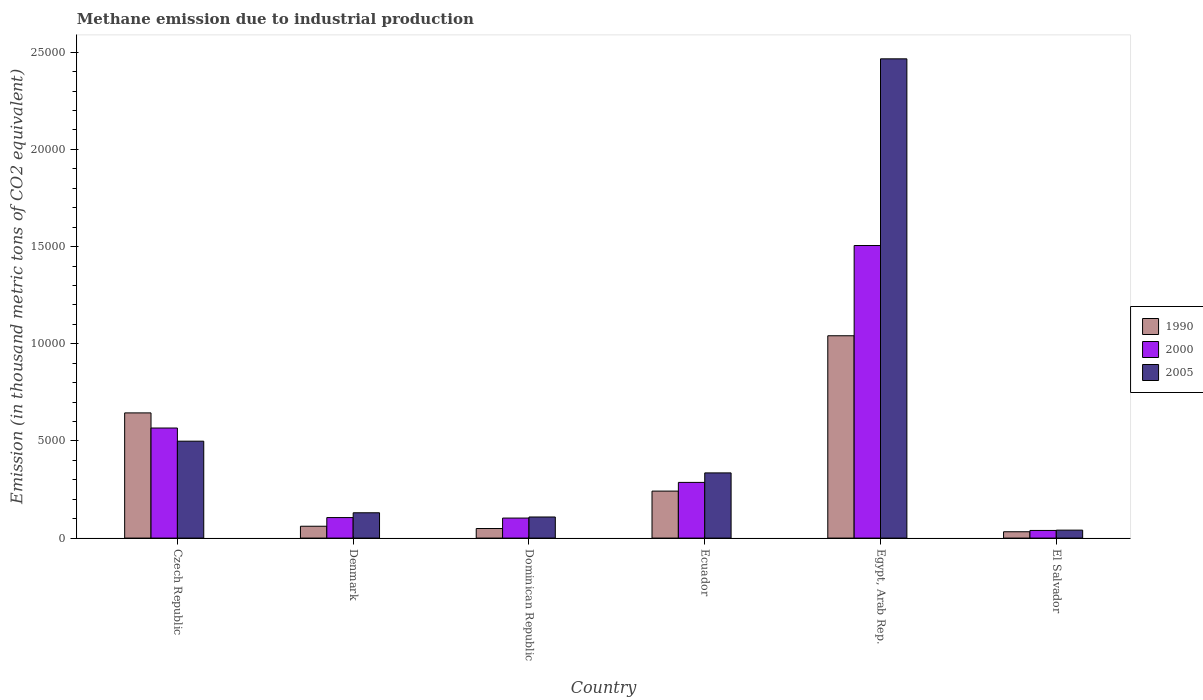How many different coloured bars are there?
Provide a succinct answer. 3. How many groups of bars are there?
Provide a succinct answer. 6. Are the number of bars per tick equal to the number of legend labels?
Ensure brevity in your answer.  Yes. How many bars are there on the 1st tick from the right?
Ensure brevity in your answer.  3. What is the label of the 4th group of bars from the left?
Your response must be concise. Ecuador. What is the amount of methane emitted in 1990 in Egypt, Arab Rep.?
Offer a very short reply. 1.04e+04. Across all countries, what is the maximum amount of methane emitted in 2005?
Provide a succinct answer. 2.47e+04. Across all countries, what is the minimum amount of methane emitted in 2005?
Provide a short and direct response. 409.3. In which country was the amount of methane emitted in 2000 maximum?
Keep it short and to the point. Egypt, Arab Rep. In which country was the amount of methane emitted in 1990 minimum?
Give a very brief answer. El Salvador. What is the total amount of methane emitted in 2000 in the graph?
Your answer should be very brief. 2.61e+04. What is the difference between the amount of methane emitted in 2000 in Denmark and that in El Salvador?
Your answer should be very brief. 662.4. What is the difference between the amount of methane emitted in 2000 in Ecuador and the amount of methane emitted in 2005 in Egypt, Arab Rep.?
Your answer should be very brief. -2.18e+04. What is the average amount of methane emitted in 1990 per country?
Give a very brief answer. 3450.03. What is the difference between the amount of methane emitted of/in 2000 and amount of methane emitted of/in 1990 in Ecuador?
Ensure brevity in your answer.  447.7. What is the ratio of the amount of methane emitted in 2000 in Denmark to that in Ecuador?
Offer a very short reply. 0.37. What is the difference between the highest and the second highest amount of methane emitted in 2000?
Make the answer very short. 2798.1. What is the difference between the highest and the lowest amount of methane emitted in 1990?
Provide a succinct answer. 1.01e+04. In how many countries, is the amount of methane emitted in 2005 greater than the average amount of methane emitted in 2005 taken over all countries?
Your answer should be compact. 1. Is the sum of the amount of methane emitted in 2005 in Czech Republic and Egypt, Arab Rep. greater than the maximum amount of methane emitted in 2000 across all countries?
Ensure brevity in your answer.  Yes. Is it the case that in every country, the sum of the amount of methane emitted in 2005 and amount of methane emitted in 1990 is greater than the amount of methane emitted in 2000?
Make the answer very short. Yes. How many bars are there?
Make the answer very short. 18. Are all the bars in the graph horizontal?
Your response must be concise. No. How many countries are there in the graph?
Provide a succinct answer. 6. Are the values on the major ticks of Y-axis written in scientific E-notation?
Your answer should be compact. No. Does the graph contain any zero values?
Provide a short and direct response. No. Does the graph contain grids?
Provide a short and direct response. No. How are the legend labels stacked?
Make the answer very short. Vertical. What is the title of the graph?
Ensure brevity in your answer.  Methane emission due to industrial production. Does "1960" appear as one of the legend labels in the graph?
Make the answer very short. No. What is the label or title of the X-axis?
Your answer should be very brief. Country. What is the label or title of the Y-axis?
Provide a short and direct response. Emission (in thousand metric tons of CO2 equivalent). What is the Emission (in thousand metric tons of CO2 equivalent) of 1990 in Czech Republic?
Provide a short and direct response. 6442.2. What is the Emission (in thousand metric tons of CO2 equivalent) in 2000 in Czech Republic?
Your response must be concise. 5664.2. What is the Emission (in thousand metric tons of CO2 equivalent) in 2005 in Czech Republic?
Give a very brief answer. 4986.9. What is the Emission (in thousand metric tons of CO2 equivalent) in 1990 in Denmark?
Ensure brevity in your answer.  609.7. What is the Emission (in thousand metric tons of CO2 equivalent) in 2000 in Denmark?
Offer a terse response. 1056. What is the Emission (in thousand metric tons of CO2 equivalent) in 2005 in Denmark?
Your answer should be very brief. 1303.1. What is the Emission (in thousand metric tons of CO2 equivalent) of 1990 in Dominican Republic?
Offer a terse response. 492.1. What is the Emission (in thousand metric tons of CO2 equivalent) in 2000 in Dominican Republic?
Provide a succinct answer. 1030.4. What is the Emission (in thousand metric tons of CO2 equivalent) in 2005 in Dominican Republic?
Make the answer very short. 1085.6. What is the Emission (in thousand metric tons of CO2 equivalent) in 1990 in Ecuador?
Provide a succinct answer. 2418.4. What is the Emission (in thousand metric tons of CO2 equivalent) of 2000 in Ecuador?
Ensure brevity in your answer.  2866.1. What is the Emission (in thousand metric tons of CO2 equivalent) of 2005 in Ecuador?
Give a very brief answer. 3354.7. What is the Emission (in thousand metric tons of CO2 equivalent) of 1990 in Egypt, Arab Rep.?
Provide a succinct answer. 1.04e+04. What is the Emission (in thousand metric tons of CO2 equivalent) of 2000 in Egypt, Arab Rep.?
Keep it short and to the point. 1.51e+04. What is the Emission (in thousand metric tons of CO2 equivalent) of 2005 in Egypt, Arab Rep.?
Keep it short and to the point. 2.47e+04. What is the Emission (in thousand metric tons of CO2 equivalent) in 1990 in El Salvador?
Your answer should be compact. 325.8. What is the Emission (in thousand metric tons of CO2 equivalent) in 2000 in El Salvador?
Your response must be concise. 393.6. What is the Emission (in thousand metric tons of CO2 equivalent) of 2005 in El Salvador?
Your response must be concise. 409.3. Across all countries, what is the maximum Emission (in thousand metric tons of CO2 equivalent) in 1990?
Your answer should be very brief. 1.04e+04. Across all countries, what is the maximum Emission (in thousand metric tons of CO2 equivalent) in 2000?
Give a very brief answer. 1.51e+04. Across all countries, what is the maximum Emission (in thousand metric tons of CO2 equivalent) in 2005?
Your response must be concise. 2.47e+04. Across all countries, what is the minimum Emission (in thousand metric tons of CO2 equivalent) in 1990?
Your answer should be very brief. 325.8. Across all countries, what is the minimum Emission (in thousand metric tons of CO2 equivalent) in 2000?
Offer a very short reply. 393.6. Across all countries, what is the minimum Emission (in thousand metric tons of CO2 equivalent) of 2005?
Provide a succinct answer. 409.3. What is the total Emission (in thousand metric tons of CO2 equivalent) of 1990 in the graph?
Keep it short and to the point. 2.07e+04. What is the total Emission (in thousand metric tons of CO2 equivalent) in 2000 in the graph?
Offer a terse response. 2.61e+04. What is the total Emission (in thousand metric tons of CO2 equivalent) in 2005 in the graph?
Provide a succinct answer. 3.58e+04. What is the difference between the Emission (in thousand metric tons of CO2 equivalent) of 1990 in Czech Republic and that in Denmark?
Keep it short and to the point. 5832.5. What is the difference between the Emission (in thousand metric tons of CO2 equivalent) of 2000 in Czech Republic and that in Denmark?
Your answer should be compact. 4608.2. What is the difference between the Emission (in thousand metric tons of CO2 equivalent) of 2005 in Czech Republic and that in Denmark?
Offer a very short reply. 3683.8. What is the difference between the Emission (in thousand metric tons of CO2 equivalent) of 1990 in Czech Republic and that in Dominican Republic?
Ensure brevity in your answer.  5950.1. What is the difference between the Emission (in thousand metric tons of CO2 equivalent) of 2000 in Czech Republic and that in Dominican Republic?
Ensure brevity in your answer.  4633.8. What is the difference between the Emission (in thousand metric tons of CO2 equivalent) of 2005 in Czech Republic and that in Dominican Republic?
Make the answer very short. 3901.3. What is the difference between the Emission (in thousand metric tons of CO2 equivalent) in 1990 in Czech Republic and that in Ecuador?
Your answer should be compact. 4023.8. What is the difference between the Emission (in thousand metric tons of CO2 equivalent) in 2000 in Czech Republic and that in Ecuador?
Give a very brief answer. 2798.1. What is the difference between the Emission (in thousand metric tons of CO2 equivalent) of 2005 in Czech Republic and that in Ecuador?
Offer a very short reply. 1632.2. What is the difference between the Emission (in thousand metric tons of CO2 equivalent) of 1990 in Czech Republic and that in Egypt, Arab Rep.?
Your answer should be compact. -3969.8. What is the difference between the Emission (in thousand metric tons of CO2 equivalent) in 2000 in Czech Republic and that in Egypt, Arab Rep.?
Give a very brief answer. -9390.7. What is the difference between the Emission (in thousand metric tons of CO2 equivalent) in 2005 in Czech Republic and that in Egypt, Arab Rep.?
Provide a short and direct response. -1.97e+04. What is the difference between the Emission (in thousand metric tons of CO2 equivalent) in 1990 in Czech Republic and that in El Salvador?
Provide a succinct answer. 6116.4. What is the difference between the Emission (in thousand metric tons of CO2 equivalent) in 2000 in Czech Republic and that in El Salvador?
Ensure brevity in your answer.  5270.6. What is the difference between the Emission (in thousand metric tons of CO2 equivalent) of 2005 in Czech Republic and that in El Salvador?
Your response must be concise. 4577.6. What is the difference between the Emission (in thousand metric tons of CO2 equivalent) of 1990 in Denmark and that in Dominican Republic?
Give a very brief answer. 117.6. What is the difference between the Emission (in thousand metric tons of CO2 equivalent) in 2000 in Denmark and that in Dominican Republic?
Offer a very short reply. 25.6. What is the difference between the Emission (in thousand metric tons of CO2 equivalent) of 2005 in Denmark and that in Dominican Republic?
Provide a succinct answer. 217.5. What is the difference between the Emission (in thousand metric tons of CO2 equivalent) of 1990 in Denmark and that in Ecuador?
Offer a very short reply. -1808.7. What is the difference between the Emission (in thousand metric tons of CO2 equivalent) of 2000 in Denmark and that in Ecuador?
Offer a terse response. -1810.1. What is the difference between the Emission (in thousand metric tons of CO2 equivalent) in 2005 in Denmark and that in Ecuador?
Give a very brief answer. -2051.6. What is the difference between the Emission (in thousand metric tons of CO2 equivalent) in 1990 in Denmark and that in Egypt, Arab Rep.?
Make the answer very short. -9802.3. What is the difference between the Emission (in thousand metric tons of CO2 equivalent) of 2000 in Denmark and that in Egypt, Arab Rep.?
Your answer should be very brief. -1.40e+04. What is the difference between the Emission (in thousand metric tons of CO2 equivalent) in 2005 in Denmark and that in Egypt, Arab Rep.?
Make the answer very short. -2.34e+04. What is the difference between the Emission (in thousand metric tons of CO2 equivalent) of 1990 in Denmark and that in El Salvador?
Ensure brevity in your answer.  283.9. What is the difference between the Emission (in thousand metric tons of CO2 equivalent) in 2000 in Denmark and that in El Salvador?
Your answer should be very brief. 662.4. What is the difference between the Emission (in thousand metric tons of CO2 equivalent) in 2005 in Denmark and that in El Salvador?
Give a very brief answer. 893.8. What is the difference between the Emission (in thousand metric tons of CO2 equivalent) in 1990 in Dominican Republic and that in Ecuador?
Your answer should be very brief. -1926.3. What is the difference between the Emission (in thousand metric tons of CO2 equivalent) of 2000 in Dominican Republic and that in Ecuador?
Keep it short and to the point. -1835.7. What is the difference between the Emission (in thousand metric tons of CO2 equivalent) of 2005 in Dominican Republic and that in Ecuador?
Make the answer very short. -2269.1. What is the difference between the Emission (in thousand metric tons of CO2 equivalent) of 1990 in Dominican Republic and that in Egypt, Arab Rep.?
Your answer should be compact. -9919.9. What is the difference between the Emission (in thousand metric tons of CO2 equivalent) of 2000 in Dominican Republic and that in Egypt, Arab Rep.?
Offer a terse response. -1.40e+04. What is the difference between the Emission (in thousand metric tons of CO2 equivalent) in 2005 in Dominican Republic and that in Egypt, Arab Rep.?
Your answer should be compact. -2.36e+04. What is the difference between the Emission (in thousand metric tons of CO2 equivalent) of 1990 in Dominican Republic and that in El Salvador?
Give a very brief answer. 166.3. What is the difference between the Emission (in thousand metric tons of CO2 equivalent) of 2000 in Dominican Republic and that in El Salvador?
Your response must be concise. 636.8. What is the difference between the Emission (in thousand metric tons of CO2 equivalent) of 2005 in Dominican Republic and that in El Salvador?
Give a very brief answer. 676.3. What is the difference between the Emission (in thousand metric tons of CO2 equivalent) in 1990 in Ecuador and that in Egypt, Arab Rep.?
Provide a succinct answer. -7993.6. What is the difference between the Emission (in thousand metric tons of CO2 equivalent) of 2000 in Ecuador and that in Egypt, Arab Rep.?
Make the answer very short. -1.22e+04. What is the difference between the Emission (in thousand metric tons of CO2 equivalent) in 2005 in Ecuador and that in Egypt, Arab Rep.?
Offer a very short reply. -2.13e+04. What is the difference between the Emission (in thousand metric tons of CO2 equivalent) in 1990 in Ecuador and that in El Salvador?
Keep it short and to the point. 2092.6. What is the difference between the Emission (in thousand metric tons of CO2 equivalent) of 2000 in Ecuador and that in El Salvador?
Provide a succinct answer. 2472.5. What is the difference between the Emission (in thousand metric tons of CO2 equivalent) of 2005 in Ecuador and that in El Salvador?
Ensure brevity in your answer.  2945.4. What is the difference between the Emission (in thousand metric tons of CO2 equivalent) in 1990 in Egypt, Arab Rep. and that in El Salvador?
Make the answer very short. 1.01e+04. What is the difference between the Emission (in thousand metric tons of CO2 equivalent) of 2000 in Egypt, Arab Rep. and that in El Salvador?
Provide a succinct answer. 1.47e+04. What is the difference between the Emission (in thousand metric tons of CO2 equivalent) in 2005 in Egypt, Arab Rep. and that in El Salvador?
Offer a terse response. 2.43e+04. What is the difference between the Emission (in thousand metric tons of CO2 equivalent) of 1990 in Czech Republic and the Emission (in thousand metric tons of CO2 equivalent) of 2000 in Denmark?
Provide a succinct answer. 5386.2. What is the difference between the Emission (in thousand metric tons of CO2 equivalent) in 1990 in Czech Republic and the Emission (in thousand metric tons of CO2 equivalent) in 2005 in Denmark?
Make the answer very short. 5139.1. What is the difference between the Emission (in thousand metric tons of CO2 equivalent) of 2000 in Czech Republic and the Emission (in thousand metric tons of CO2 equivalent) of 2005 in Denmark?
Your response must be concise. 4361.1. What is the difference between the Emission (in thousand metric tons of CO2 equivalent) of 1990 in Czech Republic and the Emission (in thousand metric tons of CO2 equivalent) of 2000 in Dominican Republic?
Ensure brevity in your answer.  5411.8. What is the difference between the Emission (in thousand metric tons of CO2 equivalent) in 1990 in Czech Republic and the Emission (in thousand metric tons of CO2 equivalent) in 2005 in Dominican Republic?
Ensure brevity in your answer.  5356.6. What is the difference between the Emission (in thousand metric tons of CO2 equivalent) in 2000 in Czech Republic and the Emission (in thousand metric tons of CO2 equivalent) in 2005 in Dominican Republic?
Keep it short and to the point. 4578.6. What is the difference between the Emission (in thousand metric tons of CO2 equivalent) in 1990 in Czech Republic and the Emission (in thousand metric tons of CO2 equivalent) in 2000 in Ecuador?
Offer a very short reply. 3576.1. What is the difference between the Emission (in thousand metric tons of CO2 equivalent) in 1990 in Czech Republic and the Emission (in thousand metric tons of CO2 equivalent) in 2005 in Ecuador?
Provide a succinct answer. 3087.5. What is the difference between the Emission (in thousand metric tons of CO2 equivalent) of 2000 in Czech Republic and the Emission (in thousand metric tons of CO2 equivalent) of 2005 in Ecuador?
Your answer should be compact. 2309.5. What is the difference between the Emission (in thousand metric tons of CO2 equivalent) in 1990 in Czech Republic and the Emission (in thousand metric tons of CO2 equivalent) in 2000 in Egypt, Arab Rep.?
Keep it short and to the point. -8612.7. What is the difference between the Emission (in thousand metric tons of CO2 equivalent) in 1990 in Czech Republic and the Emission (in thousand metric tons of CO2 equivalent) in 2005 in Egypt, Arab Rep.?
Offer a terse response. -1.82e+04. What is the difference between the Emission (in thousand metric tons of CO2 equivalent) of 2000 in Czech Republic and the Emission (in thousand metric tons of CO2 equivalent) of 2005 in Egypt, Arab Rep.?
Make the answer very short. -1.90e+04. What is the difference between the Emission (in thousand metric tons of CO2 equivalent) in 1990 in Czech Republic and the Emission (in thousand metric tons of CO2 equivalent) in 2000 in El Salvador?
Your response must be concise. 6048.6. What is the difference between the Emission (in thousand metric tons of CO2 equivalent) of 1990 in Czech Republic and the Emission (in thousand metric tons of CO2 equivalent) of 2005 in El Salvador?
Your response must be concise. 6032.9. What is the difference between the Emission (in thousand metric tons of CO2 equivalent) in 2000 in Czech Republic and the Emission (in thousand metric tons of CO2 equivalent) in 2005 in El Salvador?
Ensure brevity in your answer.  5254.9. What is the difference between the Emission (in thousand metric tons of CO2 equivalent) in 1990 in Denmark and the Emission (in thousand metric tons of CO2 equivalent) in 2000 in Dominican Republic?
Make the answer very short. -420.7. What is the difference between the Emission (in thousand metric tons of CO2 equivalent) in 1990 in Denmark and the Emission (in thousand metric tons of CO2 equivalent) in 2005 in Dominican Republic?
Your response must be concise. -475.9. What is the difference between the Emission (in thousand metric tons of CO2 equivalent) in 2000 in Denmark and the Emission (in thousand metric tons of CO2 equivalent) in 2005 in Dominican Republic?
Offer a very short reply. -29.6. What is the difference between the Emission (in thousand metric tons of CO2 equivalent) of 1990 in Denmark and the Emission (in thousand metric tons of CO2 equivalent) of 2000 in Ecuador?
Your answer should be very brief. -2256.4. What is the difference between the Emission (in thousand metric tons of CO2 equivalent) in 1990 in Denmark and the Emission (in thousand metric tons of CO2 equivalent) in 2005 in Ecuador?
Give a very brief answer. -2745. What is the difference between the Emission (in thousand metric tons of CO2 equivalent) in 2000 in Denmark and the Emission (in thousand metric tons of CO2 equivalent) in 2005 in Ecuador?
Provide a short and direct response. -2298.7. What is the difference between the Emission (in thousand metric tons of CO2 equivalent) in 1990 in Denmark and the Emission (in thousand metric tons of CO2 equivalent) in 2000 in Egypt, Arab Rep.?
Provide a short and direct response. -1.44e+04. What is the difference between the Emission (in thousand metric tons of CO2 equivalent) in 1990 in Denmark and the Emission (in thousand metric tons of CO2 equivalent) in 2005 in Egypt, Arab Rep.?
Keep it short and to the point. -2.41e+04. What is the difference between the Emission (in thousand metric tons of CO2 equivalent) in 2000 in Denmark and the Emission (in thousand metric tons of CO2 equivalent) in 2005 in Egypt, Arab Rep.?
Make the answer very short. -2.36e+04. What is the difference between the Emission (in thousand metric tons of CO2 equivalent) of 1990 in Denmark and the Emission (in thousand metric tons of CO2 equivalent) of 2000 in El Salvador?
Ensure brevity in your answer.  216.1. What is the difference between the Emission (in thousand metric tons of CO2 equivalent) of 1990 in Denmark and the Emission (in thousand metric tons of CO2 equivalent) of 2005 in El Salvador?
Ensure brevity in your answer.  200.4. What is the difference between the Emission (in thousand metric tons of CO2 equivalent) of 2000 in Denmark and the Emission (in thousand metric tons of CO2 equivalent) of 2005 in El Salvador?
Make the answer very short. 646.7. What is the difference between the Emission (in thousand metric tons of CO2 equivalent) in 1990 in Dominican Republic and the Emission (in thousand metric tons of CO2 equivalent) in 2000 in Ecuador?
Give a very brief answer. -2374. What is the difference between the Emission (in thousand metric tons of CO2 equivalent) of 1990 in Dominican Republic and the Emission (in thousand metric tons of CO2 equivalent) of 2005 in Ecuador?
Make the answer very short. -2862.6. What is the difference between the Emission (in thousand metric tons of CO2 equivalent) in 2000 in Dominican Republic and the Emission (in thousand metric tons of CO2 equivalent) in 2005 in Ecuador?
Your answer should be very brief. -2324.3. What is the difference between the Emission (in thousand metric tons of CO2 equivalent) of 1990 in Dominican Republic and the Emission (in thousand metric tons of CO2 equivalent) of 2000 in Egypt, Arab Rep.?
Keep it short and to the point. -1.46e+04. What is the difference between the Emission (in thousand metric tons of CO2 equivalent) in 1990 in Dominican Republic and the Emission (in thousand metric tons of CO2 equivalent) in 2005 in Egypt, Arab Rep.?
Ensure brevity in your answer.  -2.42e+04. What is the difference between the Emission (in thousand metric tons of CO2 equivalent) of 2000 in Dominican Republic and the Emission (in thousand metric tons of CO2 equivalent) of 2005 in Egypt, Arab Rep.?
Make the answer very short. -2.36e+04. What is the difference between the Emission (in thousand metric tons of CO2 equivalent) in 1990 in Dominican Republic and the Emission (in thousand metric tons of CO2 equivalent) in 2000 in El Salvador?
Give a very brief answer. 98.5. What is the difference between the Emission (in thousand metric tons of CO2 equivalent) of 1990 in Dominican Republic and the Emission (in thousand metric tons of CO2 equivalent) of 2005 in El Salvador?
Provide a short and direct response. 82.8. What is the difference between the Emission (in thousand metric tons of CO2 equivalent) of 2000 in Dominican Republic and the Emission (in thousand metric tons of CO2 equivalent) of 2005 in El Salvador?
Your response must be concise. 621.1. What is the difference between the Emission (in thousand metric tons of CO2 equivalent) of 1990 in Ecuador and the Emission (in thousand metric tons of CO2 equivalent) of 2000 in Egypt, Arab Rep.?
Offer a very short reply. -1.26e+04. What is the difference between the Emission (in thousand metric tons of CO2 equivalent) in 1990 in Ecuador and the Emission (in thousand metric tons of CO2 equivalent) in 2005 in Egypt, Arab Rep.?
Your response must be concise. -2.22e+04. What is the difference between the Emission (in thousand metric tons of CO2 equivalent) of 2000 in Ecuador and the Emission (in thousand metric tons of CO2 equivalent) of 2005 in Egypt, Arab Rep.?
Your answer should be very brief. -2.18e+04. What is the difference between the Emission (in thousand metric tons of CO2 equivalent) of 1990 in Ecuador and the Emission (in thousand metric tons of CO2 equivalent) of 2000 in El Salvador?
Provide a short and direct response. 2024.8. What is the difference between the Emission (in thousand metric tons of CO2 equivalent) in 1990 in Ecuador and the Emission (in thousand metric tons of CO2 equivalent) in 2005 in El Salvador?
Your answer should be compact. 2009.1. What is the difference between the Emission (in thousand metric tons of CO2 equivalent) in 2000 in Ecuador and the Emission (in thousand metric tons of CO2 equivalent) in 2005 in El Salvador?
Give a very brief answer. 2456.8. What is the difference between the Emission (in thousand metric tons of CO2 equivalent) in 1990 in Egypt, Arab Rep. and the Emission (in thousand metric tons of CO2 equivalent) in 2000 in El Salvador?
Provide a short and direct response. 1.00e+04. What is the difference between the Emission (in thousand metric tons of CO2 equivalent) in 1990 in Egypt, Arab Rep. and the Emission (in thousand metric tons of CO2 equivalent) in 2005 in El Salvador?
Your answer should be compact. 1.00e+04. What is the difference between the Emission (in thousand metric tons of CO2 equivalent) of 2000 in Egypt, Arab Rep. and the Emission (in thousand metric tons of CO2 equivalent) of 2005 in El Salvador?
Give a very brief answer. 1.46e+04. What is the average Emission (in thousand metric tons of CO2 equivalent) of 1990 per country?
Ensure brevity in your answer.  3450.03. What is the average Emission (in thousand metric tons of CO2 equivalent) of 2000 per country?
Your response must be concise. 4344.2. What is the average Emission (in thousand metric tons of CO2 equivalent) of 2005 per country?
Provide a succinct answer. 5966.92. What is the difference between the Emission (in thousand metric tons of CO2 equivalent) in 1990 and Emission (in thousand metric tons of CO2 equivalent) in 2000 in Czech Republic?
Ensure brevity in your answer.  778. What is the difference between the Emission (in thousand metric tons of CO2 equivalent) in 1990 and Emission (in thousand metric tons of CO2 equivalent) in 2005 in Czech Republic?
Provide a short and direct response. 1455.3. What is the difference between the Emission (in thousand metric tons of CO2 equivalent) of 2000 and Emission (in thousand metric tons of CO2 equivalent) of 2005 in Czech Republic?
Give a very brief answer. 677.3. What is the difference between the Emission (in thousand metric tons of CO2 equivalent) of 1990 and Emission (in thousand metric tons of CO2 equivalent) of 2000 in Denmark?
Your answer should be very brief. -446.3. What is the difference between the Emission (in thousand metric tons of CO2 equivalent) in 1990 and Emission (in thousand metric tons of CO2 equivalent) in 2005 in Denmark?
Offer a terse response. -693.4. What is the difference between the Emission (in thousand metric tons of CO2 equivalent) of 2000 and Emission (in thousand metric tons of CO2 equivalent) of 2005 in Denmark?
Provide a succinct answer. -247.1. What is the difference between the Emission (in thousand metric tons of CO2 equivalent) in 1990 and Emission (in thousand metric tons of CO2 equivalent) in 2000 in Dominican Republic?
Keep it short and to the point. -538.3. What is the difference between the Emission (in thousand metric tons of CO2 equivalent) in 1990 and Emission (in thousand metric tons of CO2 equivalent) in 2005 in Dominican Republic?
Ensure brevity in your answer.  -593.5. What is the difference between the Emission (in thousand metric tons of CO2 equivalent) of 2000 and Emission (in thousand metric tons of CO2 equivalent) of 2005 in Dominican Republic?
Provide a short and direct response. -55.2. What is the difference between the Emission (in thousand metric tons of CO2 equivalent) in 1990 and Emission (in thousand metric tons of CO2 equivalent) in 2000 in Ecuador?
Provide a short and direct response. -447.7. What is the difference between the Emission (in thousand metric tons of CO2 equivalent) of 1990 and Emission (in thousand metric tons of CO2 equivalent) of 2005 in Ecuador?
Your response must be concise. -936.3. What is the difference between the Emission (in thousand metric tons of CO2 equivalent) of 2000 and Emission (in thousand metric tons of CO2 equivalent) of 2005 in Ecuador?
Provide a short and direct response. -488.6. What is the difference between the Emission (in thousand metric tons of CO2 equivalent) in 1990 and Emission (in thousand metric tons of CO2 equivalent) in 2000 in Egypt, Arab Rep.?
Provide a short and direct response. -4642.9. What is the difference between the Emission (in thousand metric tons of CO2 equivalent) of 1990 and Emission (in thousand metric tons of CO2 equivalent) of 2005 in Egypt, Arab Rep.?
Your answer should be compact. -1.42e+04. What is the difference between the Emission (in thousand metric tons of CO2 equivalent) in 2000 and Emission (in thousand metric tons of CO2 equivalent) in 2005 in Egypt, Arab Rep.?
Offer a terse response. -9607. What is the difference between the Emission (in thousand metric tons of CO2 equivalent) in 1990 and Emission (in thousand metric tons of CO2 equivalent) in 2000 in El Salvador?
Your answer should be very brief. -67.8. What is the difference between the Emission (in thousand metric tons of CO2 equivalent) of 1990 and Emission (in thousand metric tons of CO2 equivalent) of 2005 in El Salvador?
Provide a succinct answer. -83.5. What is the difference between the Emission (in thousand metric tons of CO2 equivalent) in 2000 and Emission (in thousand metric tons of CO2 equivalent) in 2005 in El Salvador?
Your answer should be very brief. -15.7. What is the ratio of the Emission (in thousand metric tons of CO2 equivalent) in 1990 in Czech Republic to that in Denmark?
Provide a succinct answer. 10.57. What is the ratio of the Emission (in thousand metric tons of CO2 equivalent) in 2000 in Czech Republic to that in Denmark?
Ensure brevity in your answer.  5.36. What is the ratio of the Emission (in thousand metric tons of CO2 equivalent) in 2005 in Czech Republic to that in Denmark?
Give a very brief answer. 3.83. What is the ratio of the Emission (in thousand metric tons of CO2 equivalent) in 1990 in Czech Republic to that in Dominican Republic?
Your answer should be compact. 13.09. What is the ratio of the Emission (in thousand metric tons of CO2 equivalent) in 2000 in Czech Republic to that in Dominican Republic?
Give a very brief answer. 5.5. What is the ratio of the Emission (in thousand metric tons of CO2 equivalent) of 2005 in Czech Republic to that in Dominican Republic?
Offer a terse response. 4.59. What is the ratio of the Emission (in thousand metric tons of CO2 equivalent) of 1990 in Czech Republic to that in Ecuador?
Make the answer very short. 2.66. What is the ratio of the Emission (in thousand metric tons of CO2 equivalent) of 2000 in Czech Republic to that in Ecuador?
Keep it short and to the point. 1.98. What is the ratio of the Emission (in thousand metric tons of CO2 equivalent) of 2005 in Czech Republic to that in Ecuador?
Your response must be concise. 1.49. What is the ratio of the Emission (in thousand metric tons of CO2 equivalent) of 1990 in Czech Republic to that in Egypt, Arab Rep.?
Give a very brief answer. 0.62. What is the ratio of the Emission (in thousand metric tons of CO2 equivalent) in 2000 in Czech Republic to that in Egypt, Arab Rep.?
Keep it short and to the point. 0.38. What is the ratio of the Emission (in thousand metric tons of CO2 equivalent) of 2005 in Czech Republic to that in Egypt, Arab Rep.?
Provide a short and direct response. 0.2. What is the ratio of the Emission (in thousand metric tons of CO2 equivalent) of 1990 in Czech Republic to that in El Salvador?
Offer a terse response. 19.77. What is the ratio of the Emission (in thousand metric tons of CO2 equivalent) in 2000 in Czech Republic to that in El Salvador?
Ensure brevity in your answer.  14.39. What is the ratio of the Emission (in thousand metric tons of CO2 equivalent) in 2005 in Czech Republic to that in El Salvador?
Give a very brief answer. 12.18. What is the ratio of the Emission (in thousand metric tons of CO2 equivalent) in 1990 in Denmark to that in Dominican Republic?
Ensure brevity in your answer.  1.24. What is the ratio of the Emission (in thousand metric tons of CO2 equivalent) of 2000 in Denmark to that in Dominican Republic?
Offer a terse response. 1.02. What is the ratio of the Emission (in thousand metric tons of CO2 equivalent) in 2005 in Denmark to that in Dominican Republic?
Your response must be concise. 1.2. What is the ratio of the Emission (in thousand metric tons of CO2 equivalent) in 1990 in Denmark to that in Ecuador?
Provide a succinct answer. 0.25. What is the ratio of the Emission (in thousand metric tons of CO2 equivalent) of 2000 in Denmark to that in Ecuador?
Offer a terse response. 0.37. What is the ratio of the Emission (in thousand metric tons of CO2 equivalent) in 2005 in Denmark to that in Ecuador?
Make the answer very short. 0.39. What is the ratio of the Emission (in thousand metric tons of CO2 equivalent) of 1990 in Denmark to that in Egypt, Arab Rep.?
Offer a terse response. 0.06. What is the ratio of the Emission (in thousand metric tons of CO2 equivalent) in 2000 in Denmark to that in Egypt, Arab Rep.?
Ensure brevity in your answer.  0.07. What is the ratio of the Emission (in thousand metric tons of CO2 equivalent) in 2005 in Denmark to that in Egypt, Arab Rep.?
Give a very brief answer. 0.05. What is the ratio of the Emission (in thousand metric tons of CO2 equivalent) in 1990 in Denmark to that in El Salvador?
Your answer should be compact. 1.87. What is the ratio of the Emission (in thousand metric tons of CO2 equivalent) of 2000 in Denmark to that in El Salvador?
Keep it short and to the point. 2.68. What is the ratio of the Emission (in thousand metric tons of CO2 equivalent) of 2005 in Denmark to that in El Salvador?
Provide a succinct answer. 3.18. What is the ratio of the Emission (in thousand metric tons of CO2 equivalent) in 1990 in Dominican Republic to that in Ecuador?
Give a very brief answer. 0.2. What is the ratio of the Emission (in thousand metric tons of CO2 equivalent) of 2000 in Dominican Republic to that in Ecuador?
Ensure brevity in your answer.  0.36. What is the ratio of the Emission (in thousand metric tons of CO2 equivalent) of 2005 in Dominican Republic to that in Ecuador?
Offer a terse response. 0.32. What is the ratio of the Emission (in thousand metric tons of CO2 equivalent) in 1990 in Dominican Republic to that in Egypt, Arab Rep.?
Your answer should be very brief. 0.05. What is the ratio of the Emission (in thousand metric tons of CO2 equivalent) of 2000 in Dominican Republic to that in Egypt, Arab Rep.?
Offer a terse response. 0.07. What is the ratio of the Emission (in thousand metric tons of CO2 equivalent) in 2005 in Dominican Republic to that in Egypt, Arab Rep.?
Offer a terse response. 0.04. What is the ratio of the Emission (in thousand metric tons of CO2 equivalent) of 1990 in Dominican Republic to that in El Salvador?
Ensure brevity in your answer.  1.51. What is the ratio of the Emission (in thousand metric tons of CO2 equivalent) of 2000 in Dominican Republic to that in El Salvador?
Your response must be concise. 2.62. What is the ratio of the Emission (in thousand metric tons of CO2 equivalent) of 2005 in Dominican Republic to that in El Salvador?
Provide a short and direct response. 2.65. What is the ratio of the Emission (in thousand metric tons of CO2 equivalent) in 1990 in Ecuador to that in Egypt, Arab Rep.?
Provide a succinct answer. 0.23. What is the ratio of the Emission (in thousand metric tons of CO2 equivalent) of 2000 in Ecuador to that in Egypt, Arab Rep.?
Give a very brief answer. 0.19. What is the ratio of the Emission (in thousand metric tons of CO2 equivalent) of 2005 in Ecuador to that in Egypt, Arab Rep.?
Offer a very short reply. 0.14. What is the ratio of the Emission (in thousand metric tons of CO2 equivalent) in 1990 in Ecuador to that in El Salvador?
Your answer should be very brief. 7.42. What is the ratio of the Emission (in thousand metric tons of CO2 equivalent) of 2000 in Ecuador to that in El Salvador?
Give a very brief answer. 7.28. What is the ratio of the Emission (in thousand metric tons of CO2 equivalent) of 2005 in Ecuador to that in El Salvador?
Your answer should be very brief. 8.2. What is the ratio of the Emission (in thousand metric tons of CO2 equivalent) of 1990 in Egypt, Arab Rep. to that in El Salvador?
Your answer should be compact. 31.96. What is the ratio of the Emission (in thousand metric tons of CO2 equivalent) of 2000 in Egypt, Arab Rep. to that in El Salvador?
Your answer should be very brief. 38.25. What is the ratio of the Emission (in thousand metric tons of CO2 equivalent) of 2005 in Egypt, Arab Rep. to that in El Salvador?
Give a very brief answer. 60.25. What is the difference between the highest and the second highest Emission (in thousand metric tons of CO2 equivalent) of 1990?
Give a very brief answer. 3969.8. What is the difference between the highest and the second highest Emission (in thousand metric tons of CO2 equivalent) of 2000?
Give a very brief answer. 9390.7. What is the difference between the highest and the second highest Emission (in thousand metric tons of CO2 equivalent) of 2005?
Offer a very short reply. 1.97e+04. What is the difference between the highest and the lowest Emission (in thousand metric tons of CO2 equivalent) of 1990?
Offer a terse response. 1.01e+04. What is the difference between the highest and the lowest Emission (in thousand metric tons of CO2 equivalent) in 2000?
Your answer should be very brief. 1.47e+04. What is the difference between the highest and the lowest Emission (in thousand metric tons of CO2 equivalent) of 2005?
Make the answer very short. 2.43e+04. 